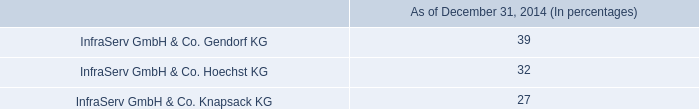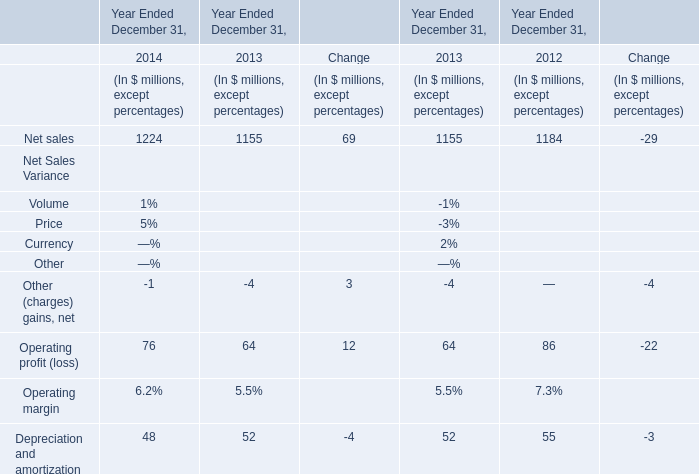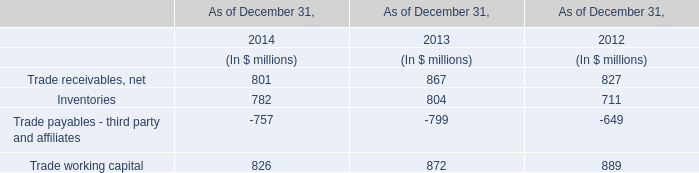Does Depreciation and amortization keeps increasing each year between 2013 and 2014? 
Answer: No. 